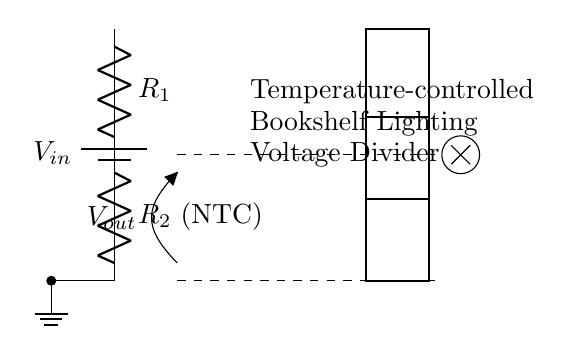What is the function of R2 in this circuit? R2 is an NTC (Negative Temperature Coefficient) resistor, which means its resistance decreases as the temperature increases. It helps to change the output voltage in response to temperature changes, thus controlling the bookshelf lighting.
Answer: NTC What does Vout represent in this circuit? Vout is the output voltage taken across the resistor R2. It indicates the voltage drop that varies based on the resistance of R2, which is influenced by temperature.
Answer: Output voltage How many resistors are present in this voltage divider? There are two resistors in this voltage divider: R1 and R2. Their values determine the proportion of the input voltage that appears at the output.
Answer: Two What would happen to Vout if the temperature increases? If the temperature increases, the resistance of R2 decreases, which would typically lead to a rise in Vout, depending on R1's value and the overall arrangement of the circuit.
Answer: Increase What type of circuit configuration is shown here? The circuit is a voltage divider configuration, specifically designed for a temperature-controlled application, utilizing series resistors to control output voltage.
Answer: Voltage divider What is the purpose of the battery in this circuit? The battery provides the input voltage (Vin) necessary for the voltage divider to function, allowing it to output a variable voltage depending on the resistance of R2.
Answer: Power supply 